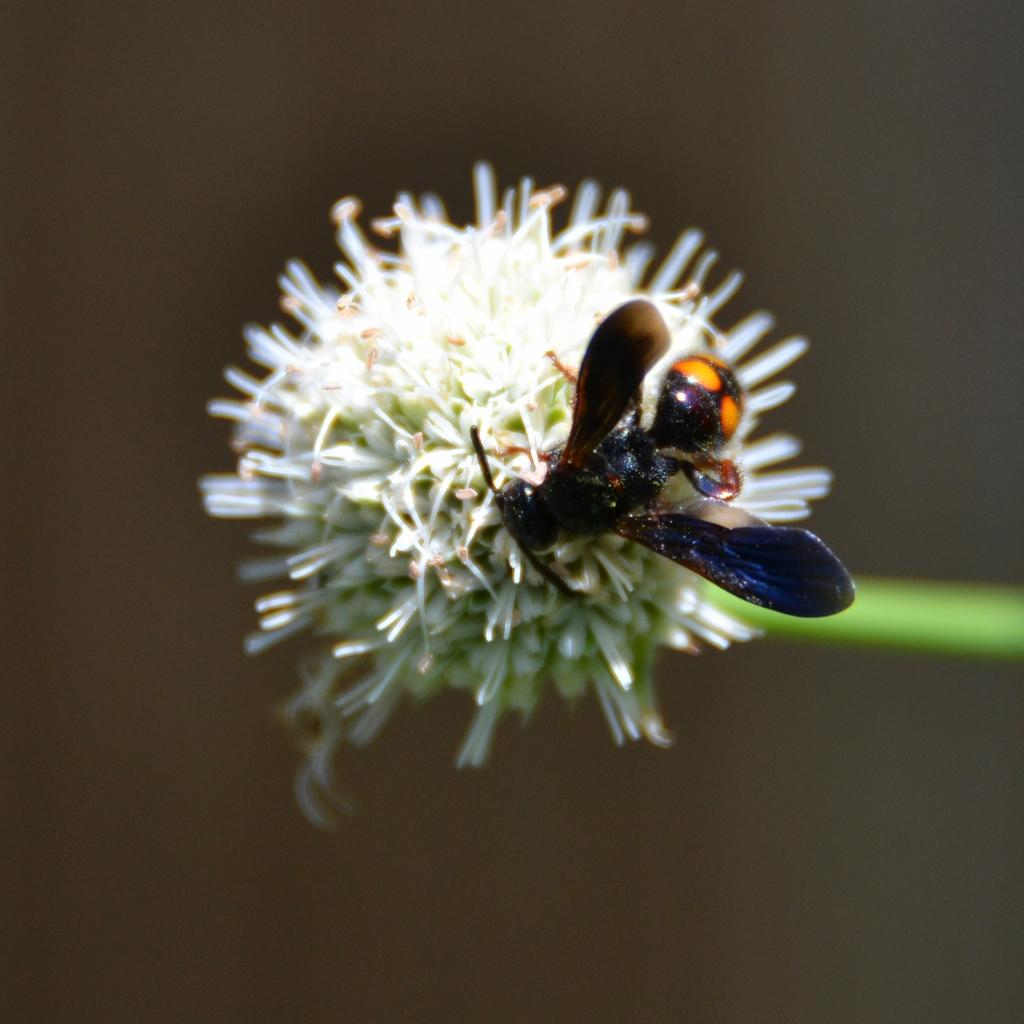What is the main subject of the image? There is an insect in the image. Where is the insect located? The insect is on a flower. Can you describe the background of the image? The background of the image is blurred. What type of corn can be seen growing in the image? There is no corn present in the image; it features an insect on a flower with a blurred background. 